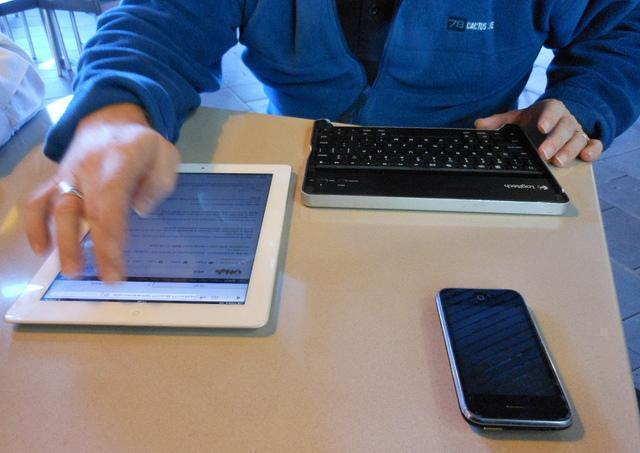Why is he touching the screen?
From the following set of four choices, select the accurate answer to respond to the question.
Options: Cleaning, navigating, massaging, taking fingerprint. Navigating. 